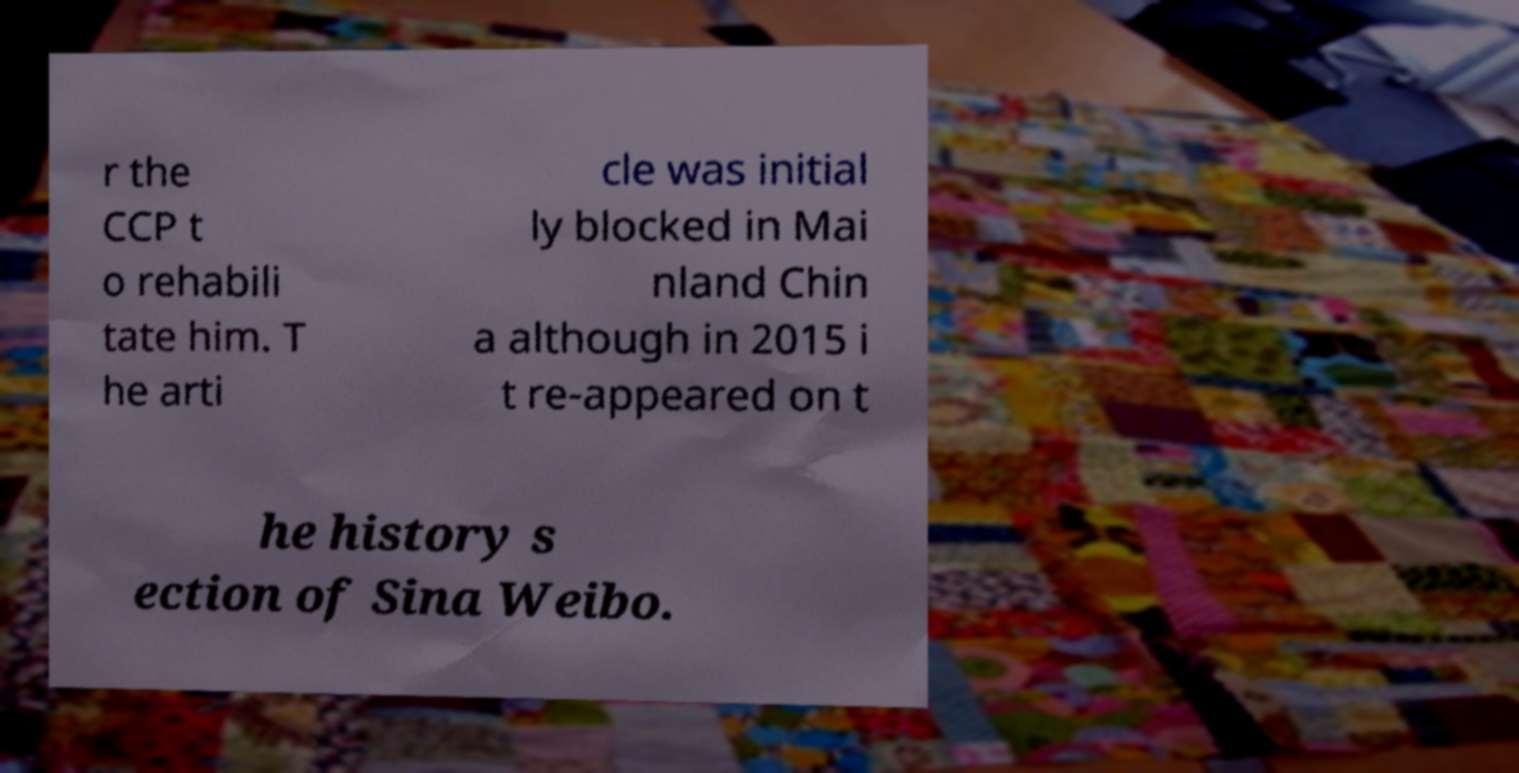I need the written content from this picture converted into text. Can you do that? r the CCP t o rehabili tate him. T he arti cle was initial ly blocked in Mai nland Chin a although in 2015 i t re-appeared on t he history s ection of Sina Weibo. 